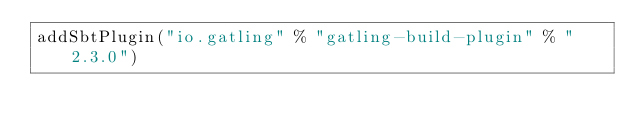Convert code to text. <code><loc_0><loc_0><loc_500><loc_500><_Scala_>addSbtPlugin("io.gatling" % "gatling-build-plugin" % "2.3.0")
</code> 